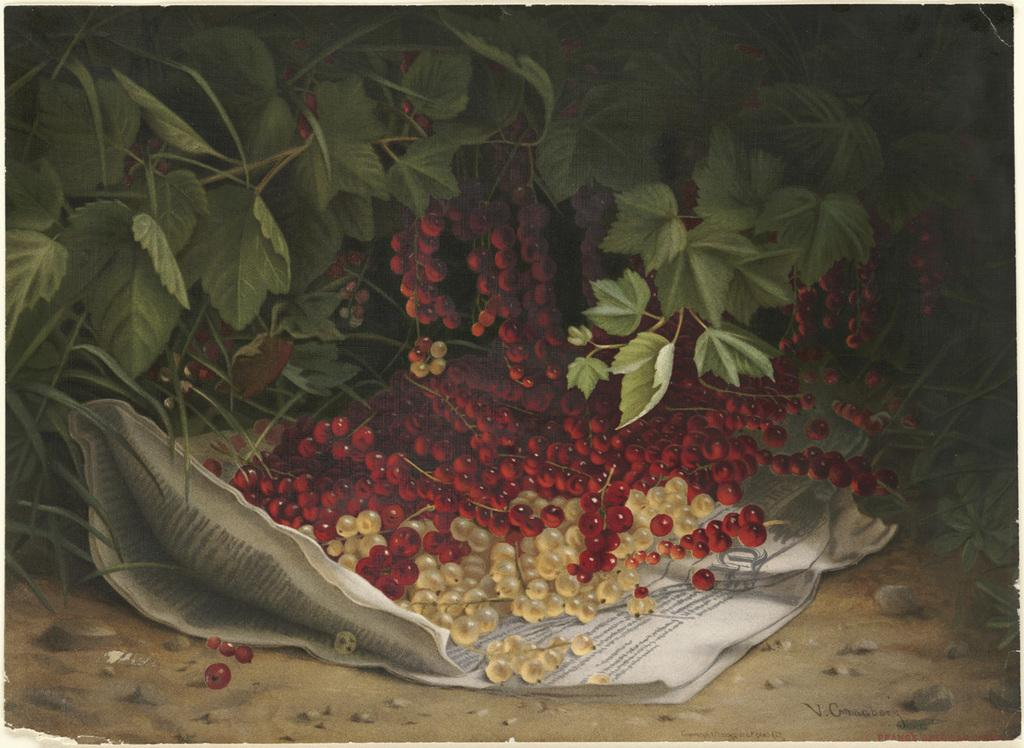What type of living organisms can be seen in the image? Plants can be seen in the image. What type of fruit is present in the image? There are berries in the image. How are the berries arranged in the image? Some berries are on a paper. What colors are the berries in the image? The berries are red and yellow in color. What type of crack can be seen in the image? There is no crack present in the image. Is there a crook in the image? There is no crook present in the image. 